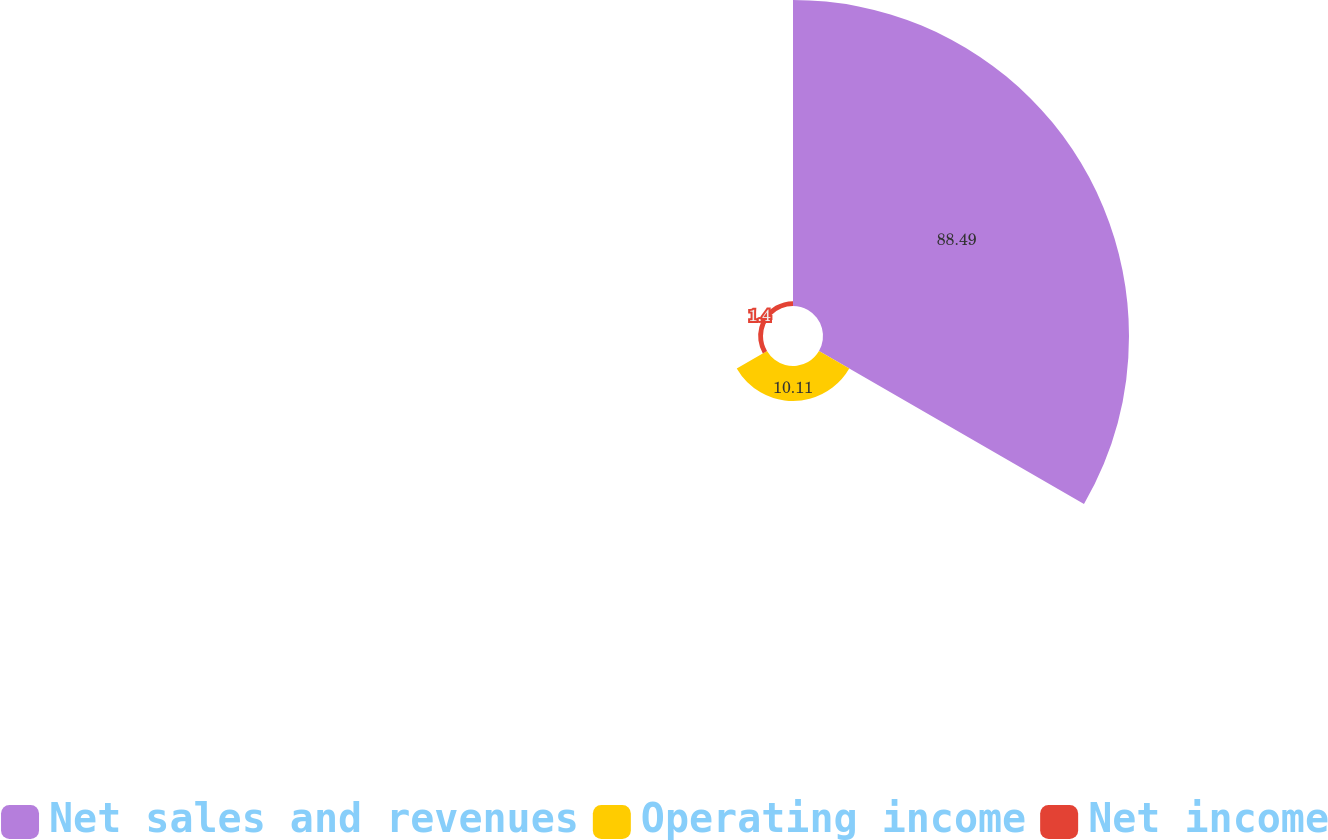Convert chart to OTSL. <chart><loc_0><loc_0><loc_500><loc_500><pie_chart><fcel>Net sales and revenues<fcel>Operating income<fcel>Net income<nl><fcel>88.49%<fcel>10.11%<fcel>1.4%<nl></chart> 